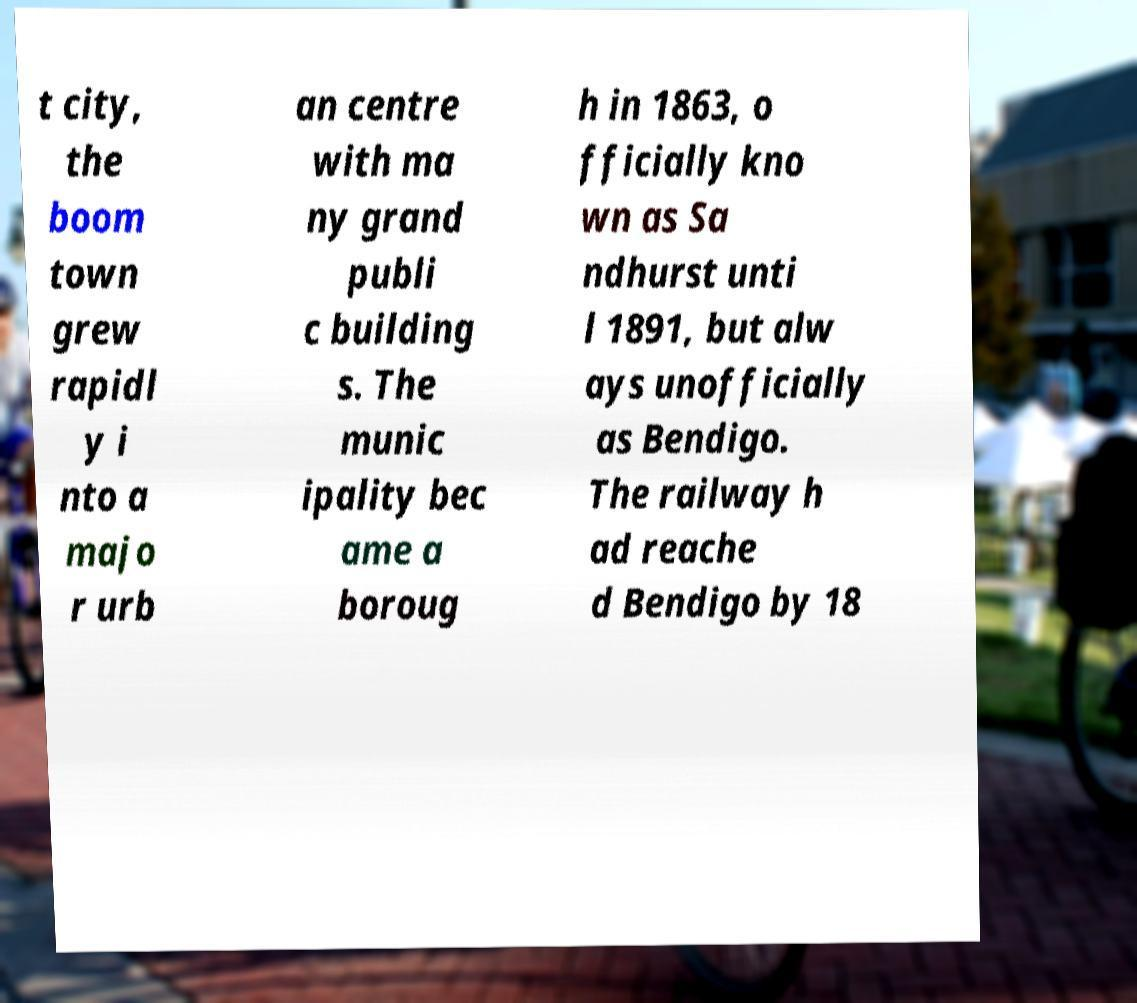Please identify and transcribe the text found in this image. t city, the boom town grew rapidl y i nto a majo r urb an centre with ma ny grand publi c building s. The munic ipality bec ame a boroug h in 1863, o fficially kno wn as Sa ndhurst unti l 1891, but alw ays unofficially as Bendigo. The railway h ad reache d Bendigo by 18 